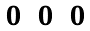<formula> <loc_0><loc_0><loc_500><loc_500>\begin{matrix} \, 0 & 0 & 0 \end{matrix}</formula> 